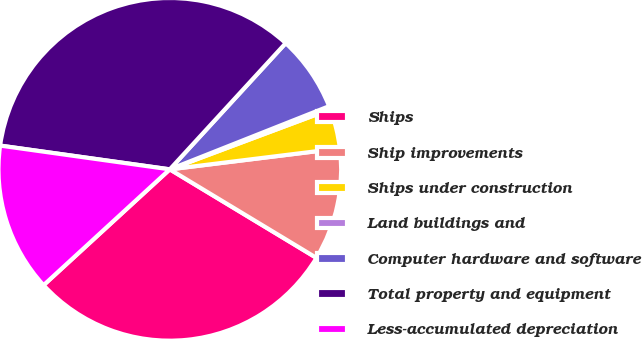Convert chart. <chart><loc_0><loc_0><loc_500><loc_500><pie_chart><fcel>Ships<fcel>Ship improvements<fcel>Ships under construction<fcel>Land buildings and<fcel>Computer hardware and software<fcel>Total property and equipment<fcel>Less-accumulated depreciation<nl><fcel>29.54%<fcel>10.6%<fcel>3.74%<fcel>0.31%<fcel>7.17%<fcel>34.61%<fcel>14.03%<nl></chart> 